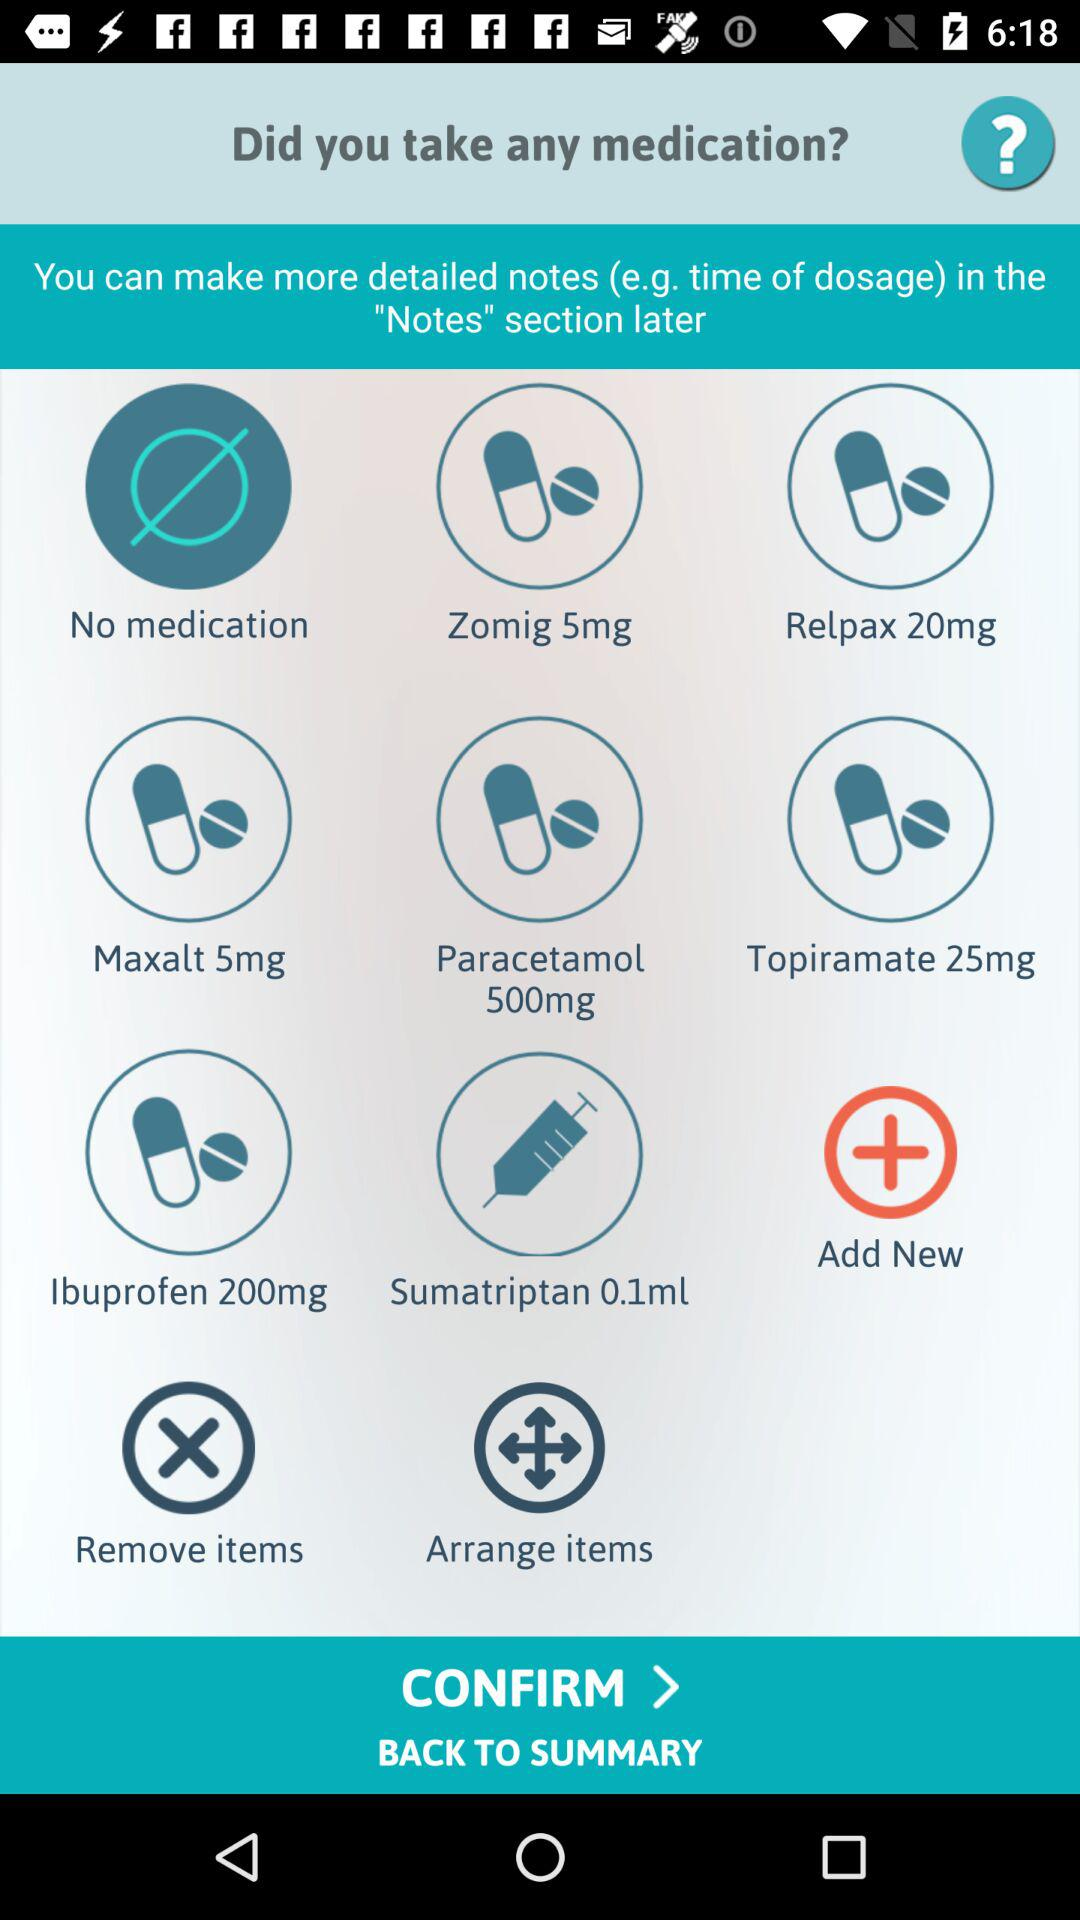What's the dosage of "Paracetamol" medication in milligrams? The dosage of "Paracetamol" medication is 500 milligrams. 